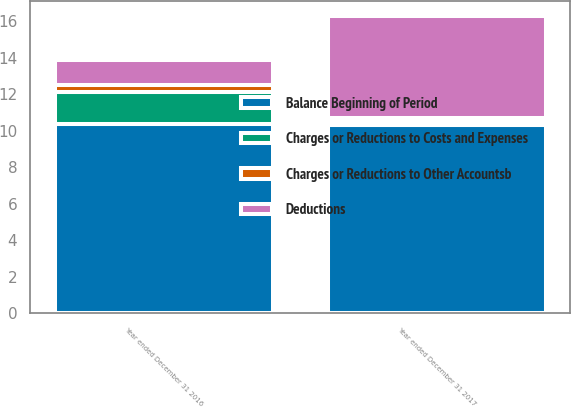<chart> <loc_0><loc_0><loc_500><loc_500><stacked_bar_chart><ecel><fcel>Year ended December 31 2016<fcel>Year ended December 31 2017<nl><fcel>Balance Beginning of Period<fcel>10.4<fcel>10.3<nl><fcel>Deductions<fcel>1.4<fcel>5.6<nl><fcel>Charges or Reductions to Costs and Expenses<fcel>1.7<fcel>0.2<nl><fcel>Charges or Reductions to Other Accountsb<fcel>0.4<fcel>0.2<nl></chart> 